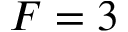Convert formula to latex. <formula><loc_0><loc_0><loc_500><loc_500>F = 3</formula> 